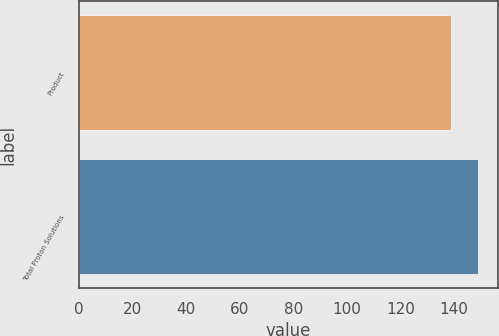<chart> <loc_0><loc_0><loc_500><loc_500><bar_chart><fcel>Product<fcel>Total Proton Solutions<nl><fcel>138.9<fcel>148.9<nl></chart> 